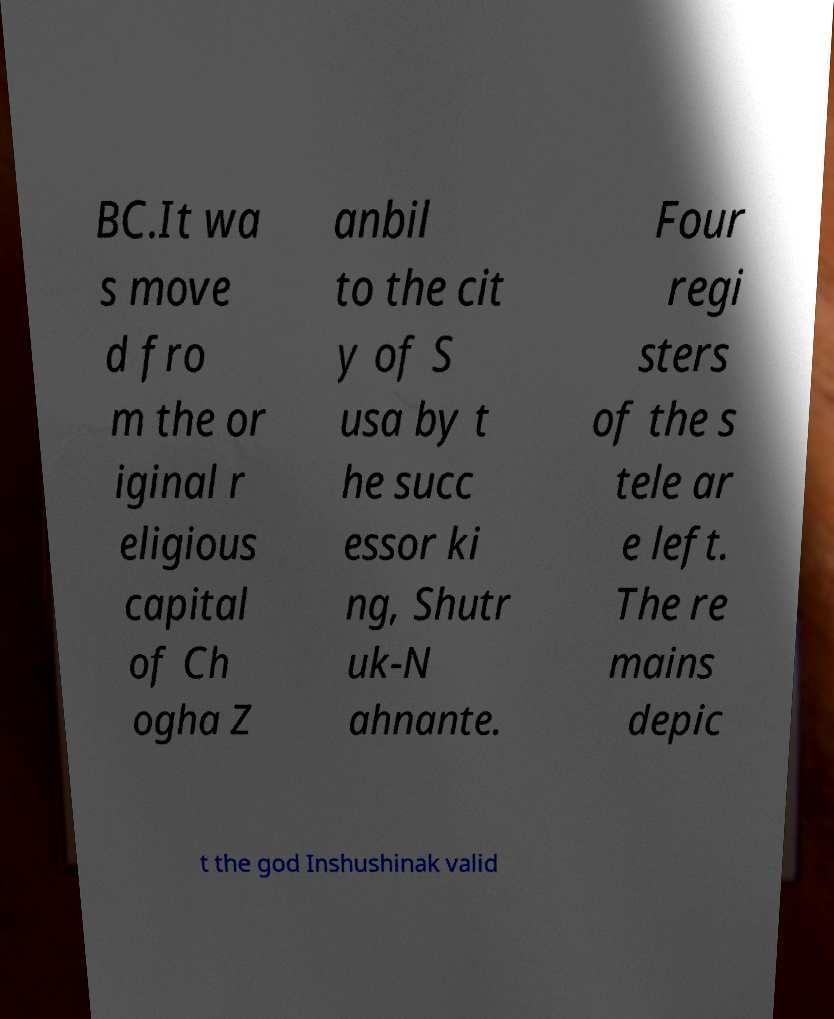Can you read and provide the text displayed in the image?This photo seems to have some interesting text. Can you extract and type it out for me? BC.It wa s move d fro m the or iginal r eligious capital of Ch ogha Z anbil to the cit y of S usa by t he succ essor ki ng, Shutr uk-N ahnante. Four regi sters of the s tele ar e left. The re mains depic t the god Inshushinak valid 